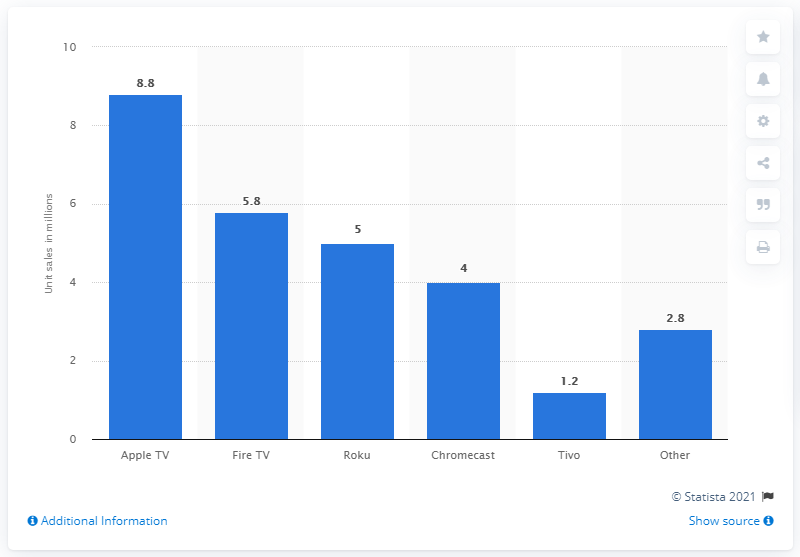Identify some key points in this picture. Apple TV streaming device forecast to sell 8.8 units in the United States in 2014. 